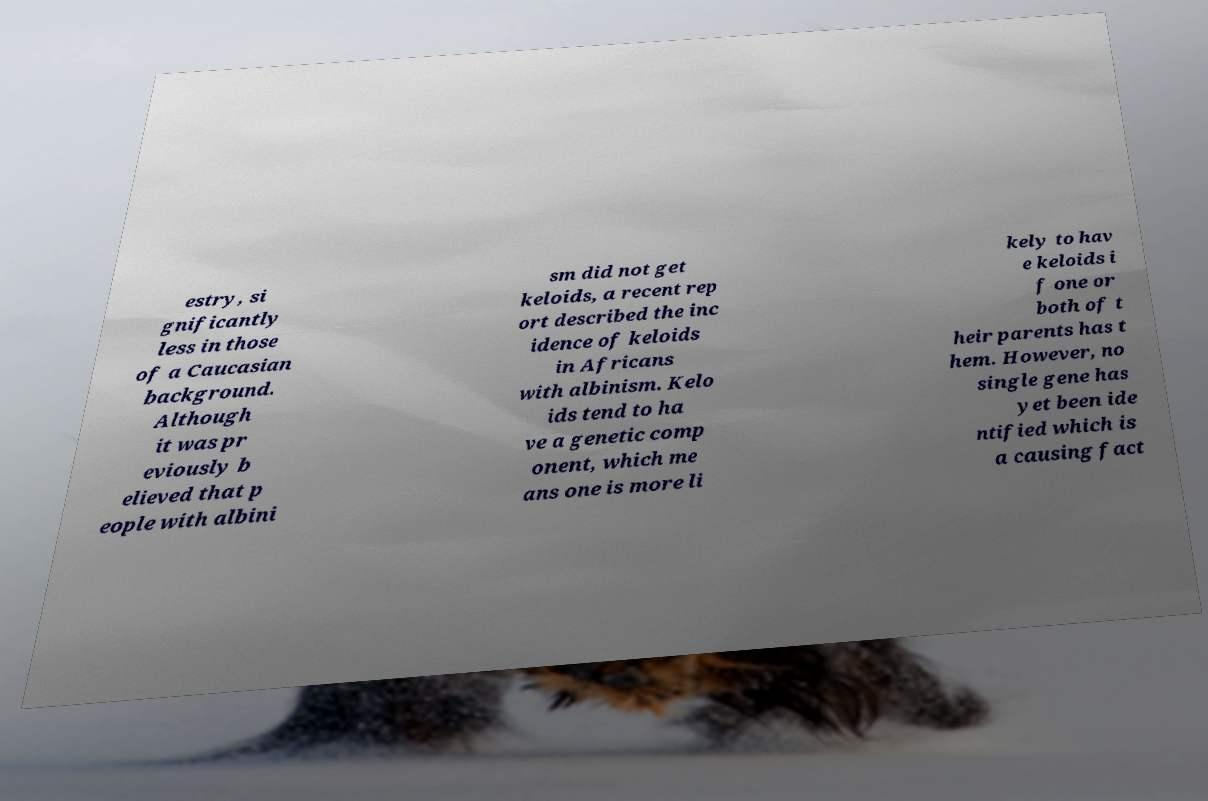Could you extract and type out the text from this image? estry, si gnificantly less in those of a Caucasian background. Although it was pr eviously b elieved that p eople with albini sm did not get keloids, a recent rep ort described the inc idence of keloids in Africans with albinism. Kelo ids tend to ha ve a genetic comp onent, which me ans one is more li kely to hav e keloids i f one or both of t heir parents has t hem. However, no single gene has yet been ide ntified which is a causing fact 